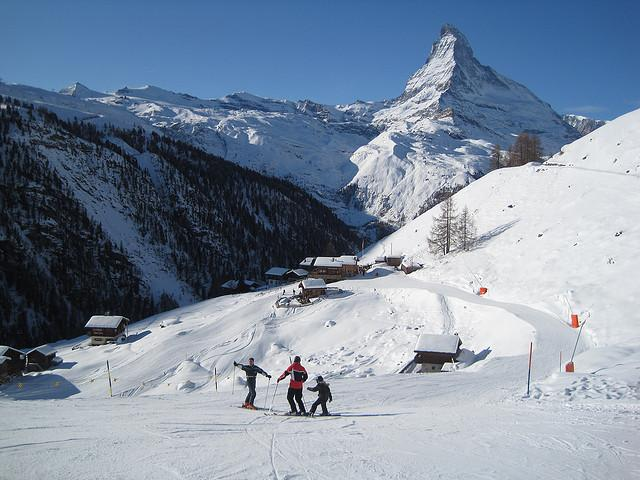What types of trees are these? Please explain your reasoning. evergreens. People are skiing on a snowy mountain with green trees. evergreens are green in the winter. 